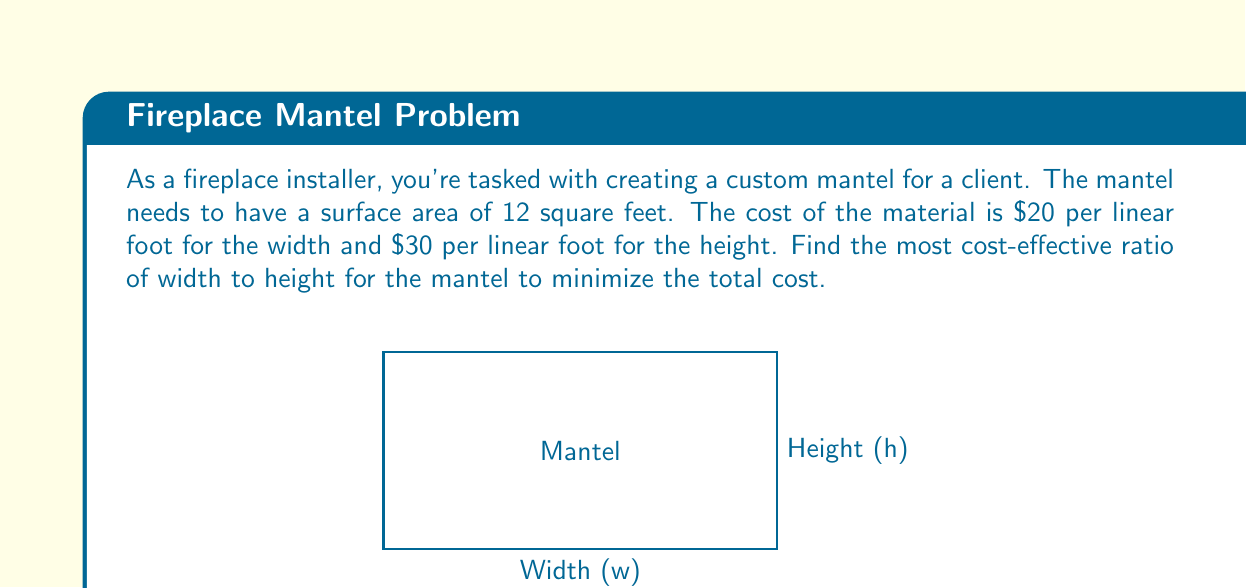Help me with this question. Let's approach this step-by-step:

1) Let $w$ be the width and $h$ be the height of the mantel.

2) Given that the surface area is 12 square feet, we can write:
   $$ w \cdot h = 12 $$

3) The total cost $C$ is given by:
   $$ C = 20w + 30h $$

4) We need to express this in terms of one variable. Let's use $w$:
   $$ h = \frac{12}{w} $$

5) Substituting this into the cost equation:
   $$ C = 20w + 30 \cdot \frac{12}{w} = 20w + \frac{360}{w} $$

6) To find the minimum cost, we differentiate $C$ with respect to $w$ and set it to zero:
   $$ \frac{dC}{dw} = 20 - \frac{360}{w^2} = 0 $$

7) Solving this equation:
   $$ 20 = \frac{360}{w^2} $$
   $$ w^2 = 18 $$
   $$ w = \sqrt{18} = 3\sqrt{2} $$

8) The corresponding height is:
   $$ h = \frac{12}{w} = \frac{12}{3\sqrt{2}} = 2\sqrt{2} $$

9) The ratio of width to height is:
   $$ \frac{w}{h} = \frac{3\sqrt{2}}{2\sqrt{2}} = \frac{3}{2} $$

Therefore, the most cost-effective ratio of width to height is 3:2.
Answer: 3:2 